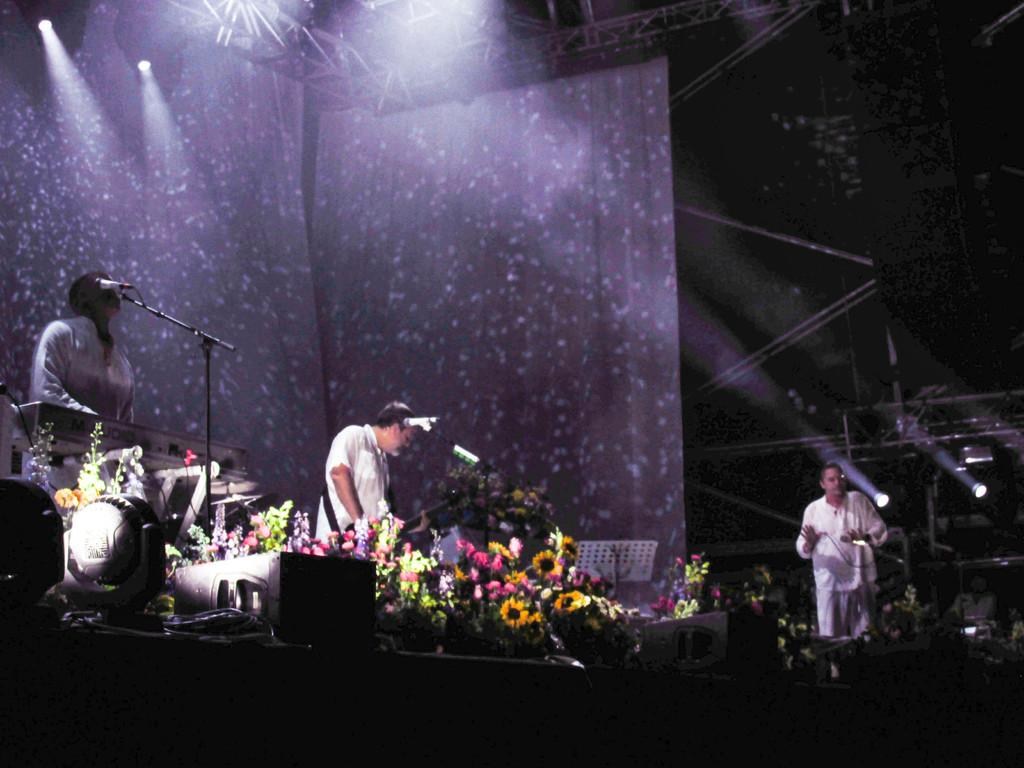What type of living organisms can be seen in the image? There are flowers in the image. Can you describe the people in the image? There are people in the image. What is visible at the top of the image? There are lights visible at the top of the image. What objects can be seen in the image besides flowers and people? There are rods in the image. What type of sponge is being used by the people in the image to balance their income? There is no sponge or mention of income in the image; it features flowers, people, lights, and rods. 